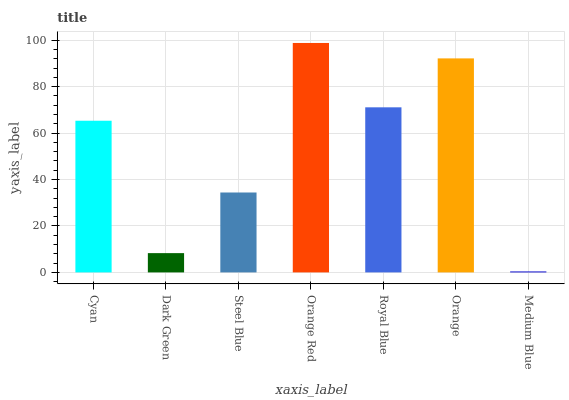Is Medium Blue the minimum?
Answer yes or no. Yes. Is Orange Red the maximum?
Answer yes or no. Yes. Is Dark Green the minimum?
Answer yes or no. No. Is Dark Green the maximum?
Answer yes or no. No. Is Cyan greater than Dark Green?
Answer yes or no. Yes. Is Dark Green less than Cyan?
Answer yes or no. Yes. Is Dark Green greater than Cyan?
Answer yes or no. No. Is Cyan less than Dark Green?
Answer yes or no. No. Is Cyan the high median?
Answer yes or no. Yes. Is Cyan the low median?
Answer yes or no. Yes. Is Orange Red the high median?
Answer yes or no. No. Is Orange the low median?
Answer yes or no. No. 